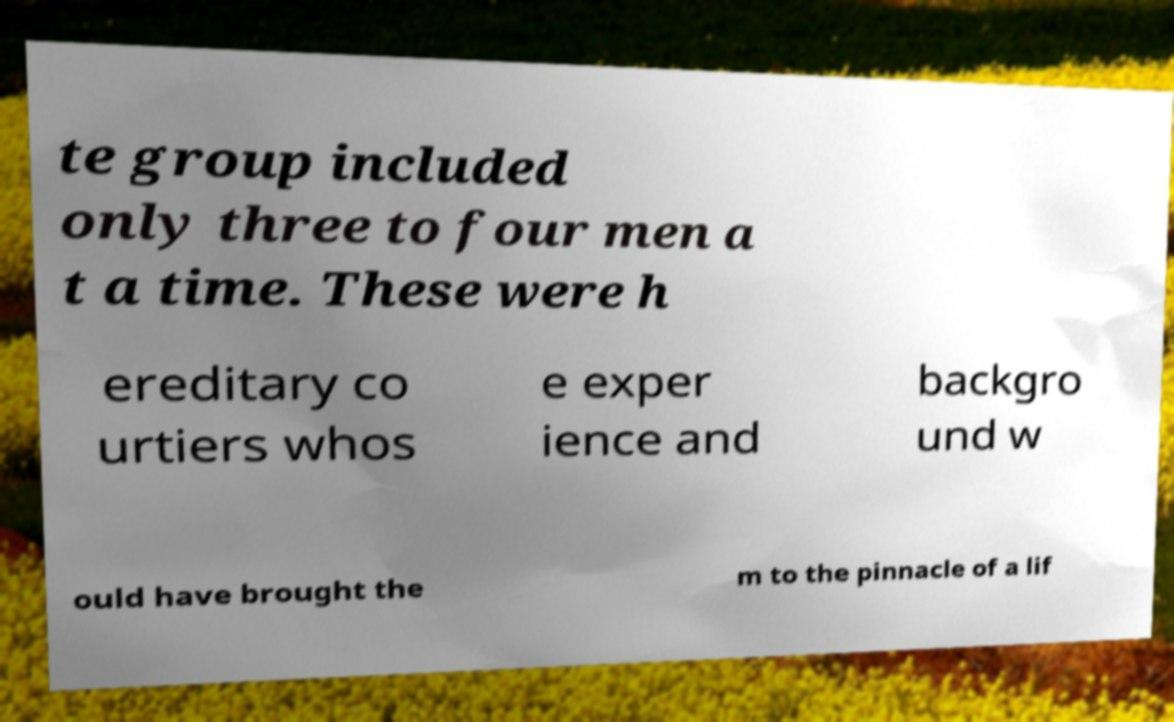Please read and relay the text visible in this image. What does it say? te group included only three to four men a t a time. These were h ereditary co urtiers whos e exper ience and backgro und w ould have brought the m to the pinnacle of a lif 